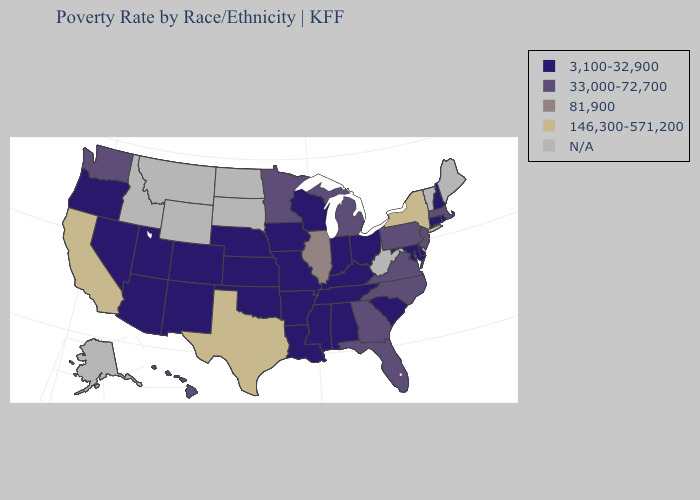What is the highest value in the South ?
Quick response, please. 146,300-571,200. Does the map have missing data?
Keep it brief. Yes. Name the states that have a value in the range N/A?
Concise answer only. Alaska, Idaho, Maine, Montana, North Dakota, South Dakota, Vermont, West Virginia, Wyoming. What is the highest value in the MidWest ?
Be succinct. 81,900. What is the value of Florida?
Give a very brief answer. 33,000-72,700. Does the first symbol in the legend represent the smallest category?
Give a very brief answer. Yes. Does Hawaii have the lowest value in the USA?
Short answer required. No. What is the value of Georgia?
Quick response, please. 33,000-72,700. Among the states that border Pennsylvania , does New Jersey have the lowest value?
Write a very short answer. No. Does North Carolina have the lowest value in the USA?
Write a very short answer. No. Does Arkansas have the highest value in the USA?
Answer briefly. No. Which states have the highest value in the USA?
Write a very short answer. California, New York, Texas. Is the legend a continuous bar?
Quick response, please. No. 